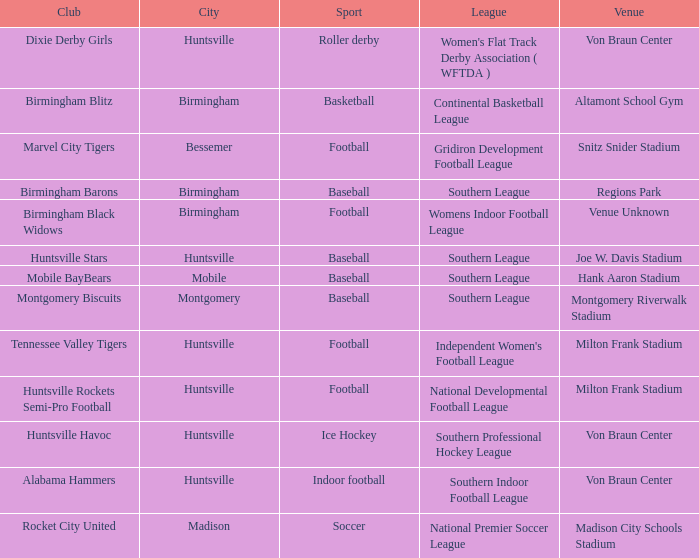What sport did the montgomery biscuits club participate in? Baseball. 